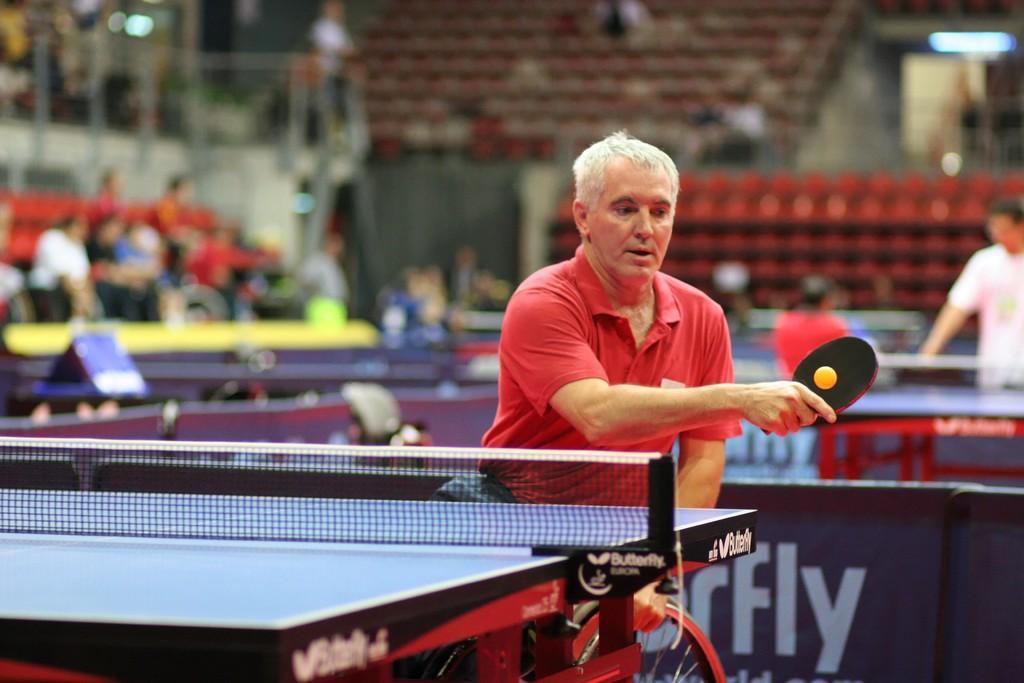In one or two sentences, can you explain what this image depicts? In this image we can see a group of people. In the center of the image we can see a person sitting in a wheelchair is holding a bat in his hand. On the left side of the image we can see a net on the table. On the right side of the image we can see a person standing. In the background, we can see some chairs, poles and some lights. At the bottom of the image we can see a board with some text. 